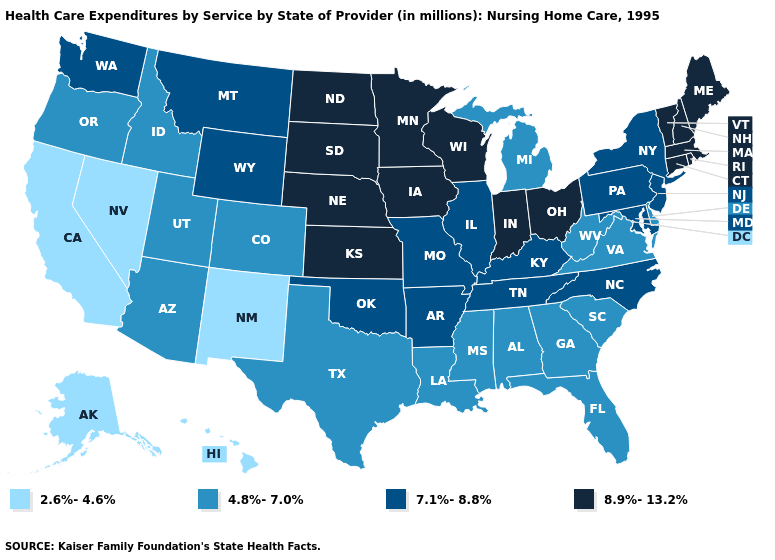Does Vermont have the same value as Arkansas?
Answer briefly. No. What is the highest value in the West ?
Concise answer only. 7.1%-8.8%. Name the states that have a value in the range 2.6%-4.6%?
Write a very short answer. Alaska, California, Hawaii, Nevada, New Mexico. What is the value of West Virginia?
Answer briefly. 4.8%-7.0%. Does Georgia have the lowest value in the USA?
Short answer required. No. Name the states that have a value in the range 8.9%-13.2%?
Quick response, please. Connecticut, Indiana, Iowa, Kansas, Maine, Massachusetts, Minnesota, Nebraska, New Hampshire, North Dakota, Ohio, Rhode Island, South Dakota, Vermont, Wisconsin. What is the lowest value in the USA?
Concise answer only. 2.6%-4.6%. Name the states that have a value in the range 7.1%-8.8%?
Short answer required. Arkansas, Illinois, Kentucky, Maryland, Missouri, Montana, New Jersey, New York, North Carolina, Oklahoma, Pennsylvania, Tennessee, Washington, Wyoming. What is the value of New Jersey?
Write a very short answer. 7.1%-8.8%. Does Washington have the highest value in the USA?
Answer briefly. No. Among the states that border New York , which have the lowest value?
Give a very brief answer. New Jersey, Pennsylvania. Does the first symbol in the legend represent the smallest category?
Short answer required. Yes. Name the states that have a value in the range 2.6%-4.6%?
Give a very brief answer. Alaska, California, Hawaii, Nevada, New Mexico. Does the map have missing data?
Write a very short answer. No. Among the states that border South Dakota , which have the highest value?
Answer briefly. Iowa, Minnesota, Nebraska, North Dakota. 